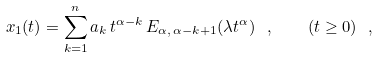<formula> <loc_0><loc_0><loc_500><loc_500>x _ { 1 } ( t ) = \sum _ { k = 1 } ^ { n } a _ { k } \, t ^ { \alpha - k } \, E _ { \alpha , \, \alpha - k + 1 } ( \lambda t ^ { \alpha } ) \ , \quad ( t \geq 0 ) \ , \</formula> 